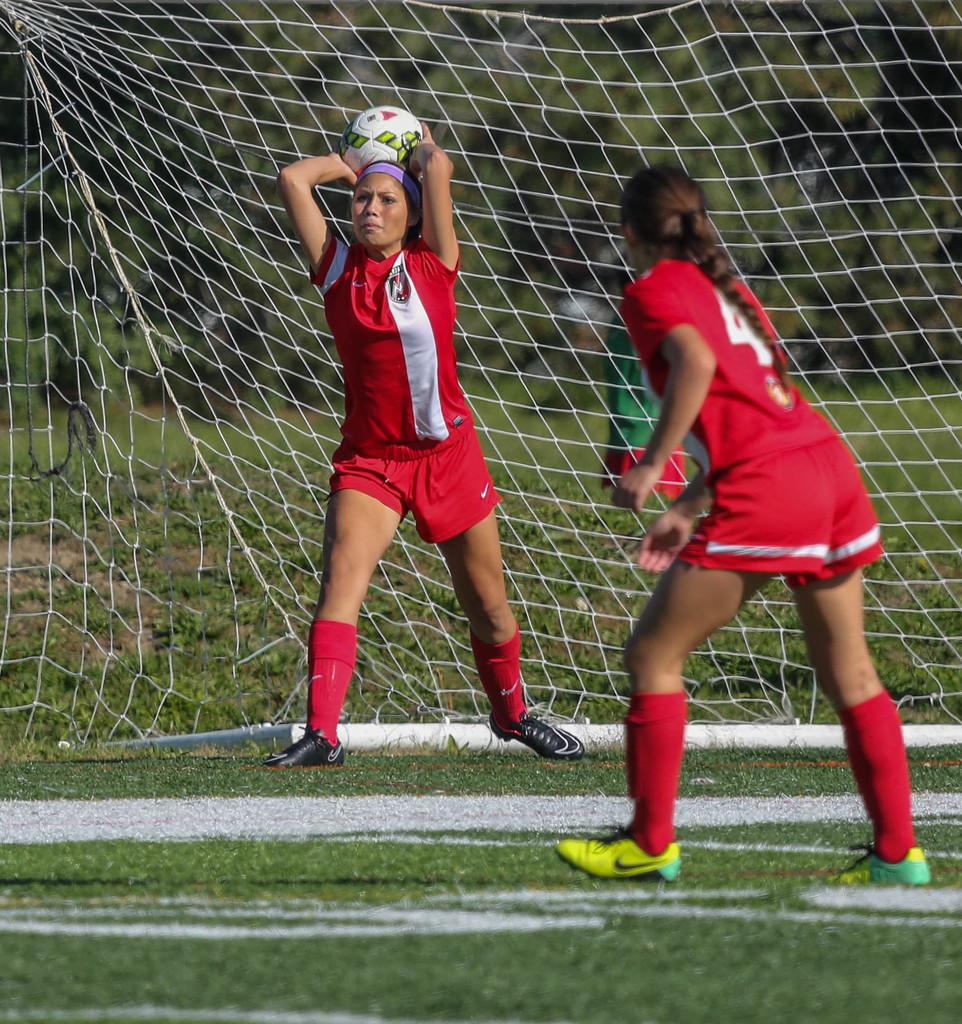How many people are in the image? There are two persons in the image. What are the persons doing in the image? One person is throwing a ball, and both persons are on the ground. What type of surface are the persons on? There is grass in the image, which suggests that the persons are on a grassy surface. What else can be seen in the image besides the persons and the ball? There is a mesh in the image. What type of trip is the turkey taking in the image? There is no turkey present in the image, so it is not possible to answer that question. 